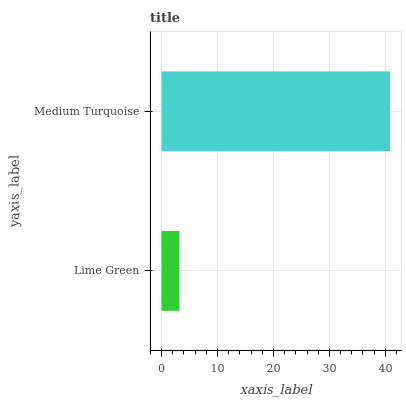Is Lime Green the minimum?
Answer yes or no. Yes. Is Medium Turquoise the maximum?
Answer yes or no. Yes. Is Medium Turquoise the minimum?
Answer yes or no. No. Is Medium Turquoise greater than Lime Green?
Answer yes or no. Yes. Is Lime Green less than Medium Turquoise?
Answer yes or no. Yes. Is Lime Green greater than Medium Turquoise?
Answer yes or no. No. Is Medium Turquoise less than Lime Green?
Answer yes or no. No. Is Medium Turquoise the high median?
Answer yes or no. Yes. Is Lime Green the low median?
Answer yes or no. Yes. Is Lime Green the high median?
Answer yes or no. No. Is Medium Turquoise the low median?
Answer yes or no. No. 